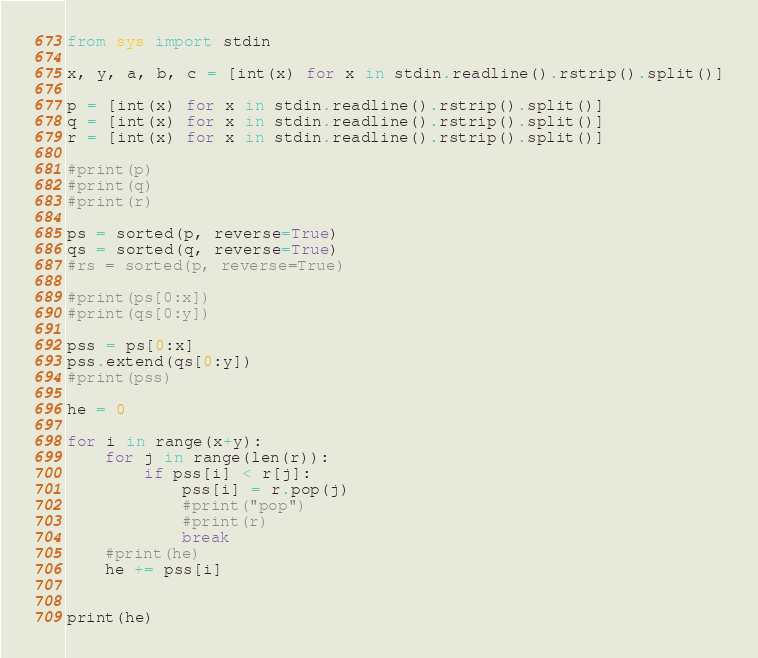<code> <loc_0><loc_0><loc_500><loc_500><_Python_>from sys import stdin

x, y, a, b, c = [int(x) for x in stdin.readline().rstrip().split()]

p = [int(x) for x in stdin.readline().rstrip().split()]
q = [int(x) for x in stdin.readline().rstrip().split()]
r = [int(x) for x in stdin.readline().rstrip().split()]

#print(p)
#print(q)
#print(r)

ps = sorted(p, reverse=True)
qs = sorted(q, reverse=True)
#rs = sorted(p, reverse=True)

#print(ps[0:x])
#print(qs[0:y])

pss = ps[0:x]
pss.extend(qs[0:y])
#print(pss)

he = 0

for i in range(x+y):
    for j in range(len(r)):
        if pss[i] < r[j]:
            pss[i] = r.pop(j)
            #print("pop")
            #print(r)
            break
    #print(he)
    he += pss[i]


print(he)</code> 